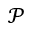<formula> <loc_0><loc_0><loc_500><loc_500>\mathcal { P }</formula> 